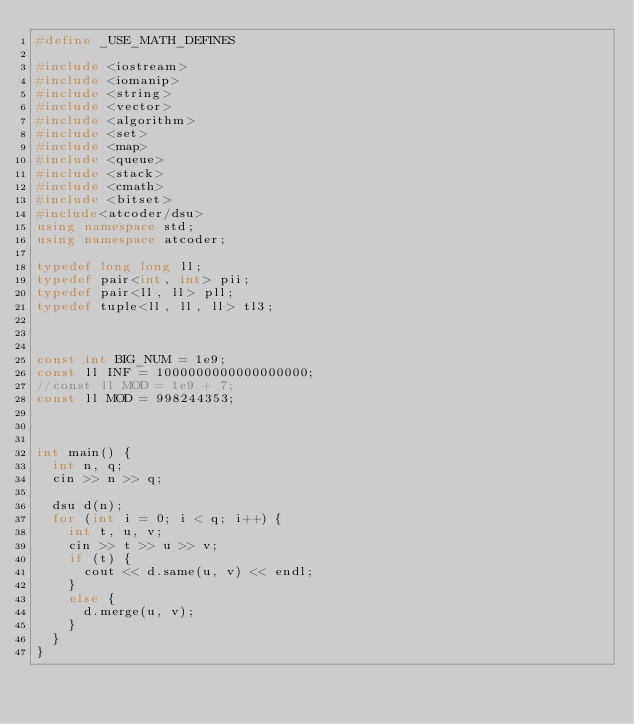<code> <loc_0><loc_0><loc_500><loc_500><_C++_>#define _USE_MATH_DEFINES

#include <iostream>
#include <iomanip>
#include <string>
#include <vector>
#include <algorithm>
#include <set>
#include <map>
#include <queue>
#include <stack>
#include <cmath>
#include <bitset>
#include<atcoder/dsu>
using namespace std;
using namespace atcoder;

typedef long long ll;
typedef pair<int, int> pii;
typedef pair<ll, ll> pll;
typedef tuple<ll, ll, ll> tl3;



const int BIG_NUM = 1e9;
const ll INF = 1000000000000000000;
//const ll MOD = 1e9 + 7;
const ll MOD = 998244353;



int main() {
	int n, q;
	cin >> n >> q;
	
	dsu d(n);
	for (int i = 0; i < q; i++) {
		int t, u, v;
		cin >> t >> u >> v;
		if (t) {
			cout << d.same(u, v) << endl;
		}
		else {
			d.merge(u, v);
		}
	}
}</code> 